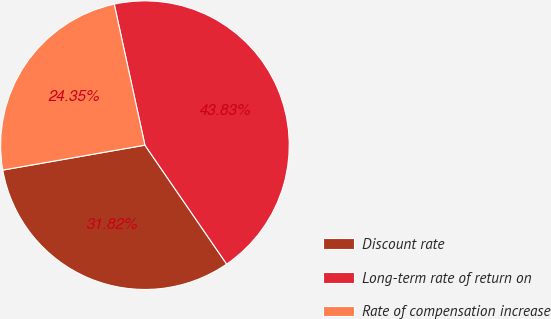Convert chart to OTSL. <chart><loc_0><loc_0><loc_500><loc_500><pie_chart><fcel>Discount rate<fcel>Long-term rate of return on<fcel>Rate of compensation increase<nl><fcel>31.82%<fcel>43.83%<fcel>24.35%<nl></chart> 